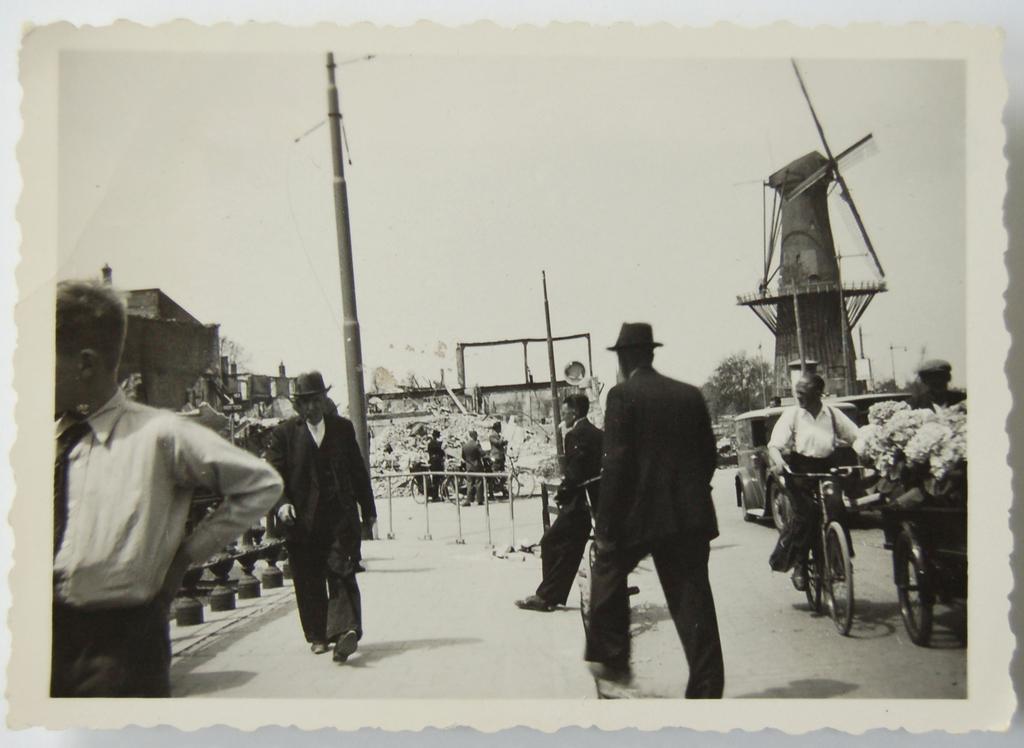Please provide a concise description of this image. In this image I can see number of people, few vehicles and on the right side I can see one person is sitting on the bicycle. In the background I can see few poles, a building and a windmill. I can also see few trees and I can see this image is black and white in colour. 